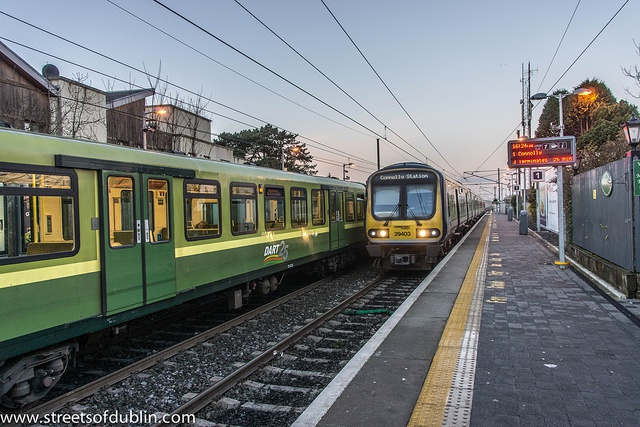Describe the objects in this image and their specific colors. I can see train in darkgray, black, darkgreen, and olive tones and train in darkgray, black, and gray tones in this image. 